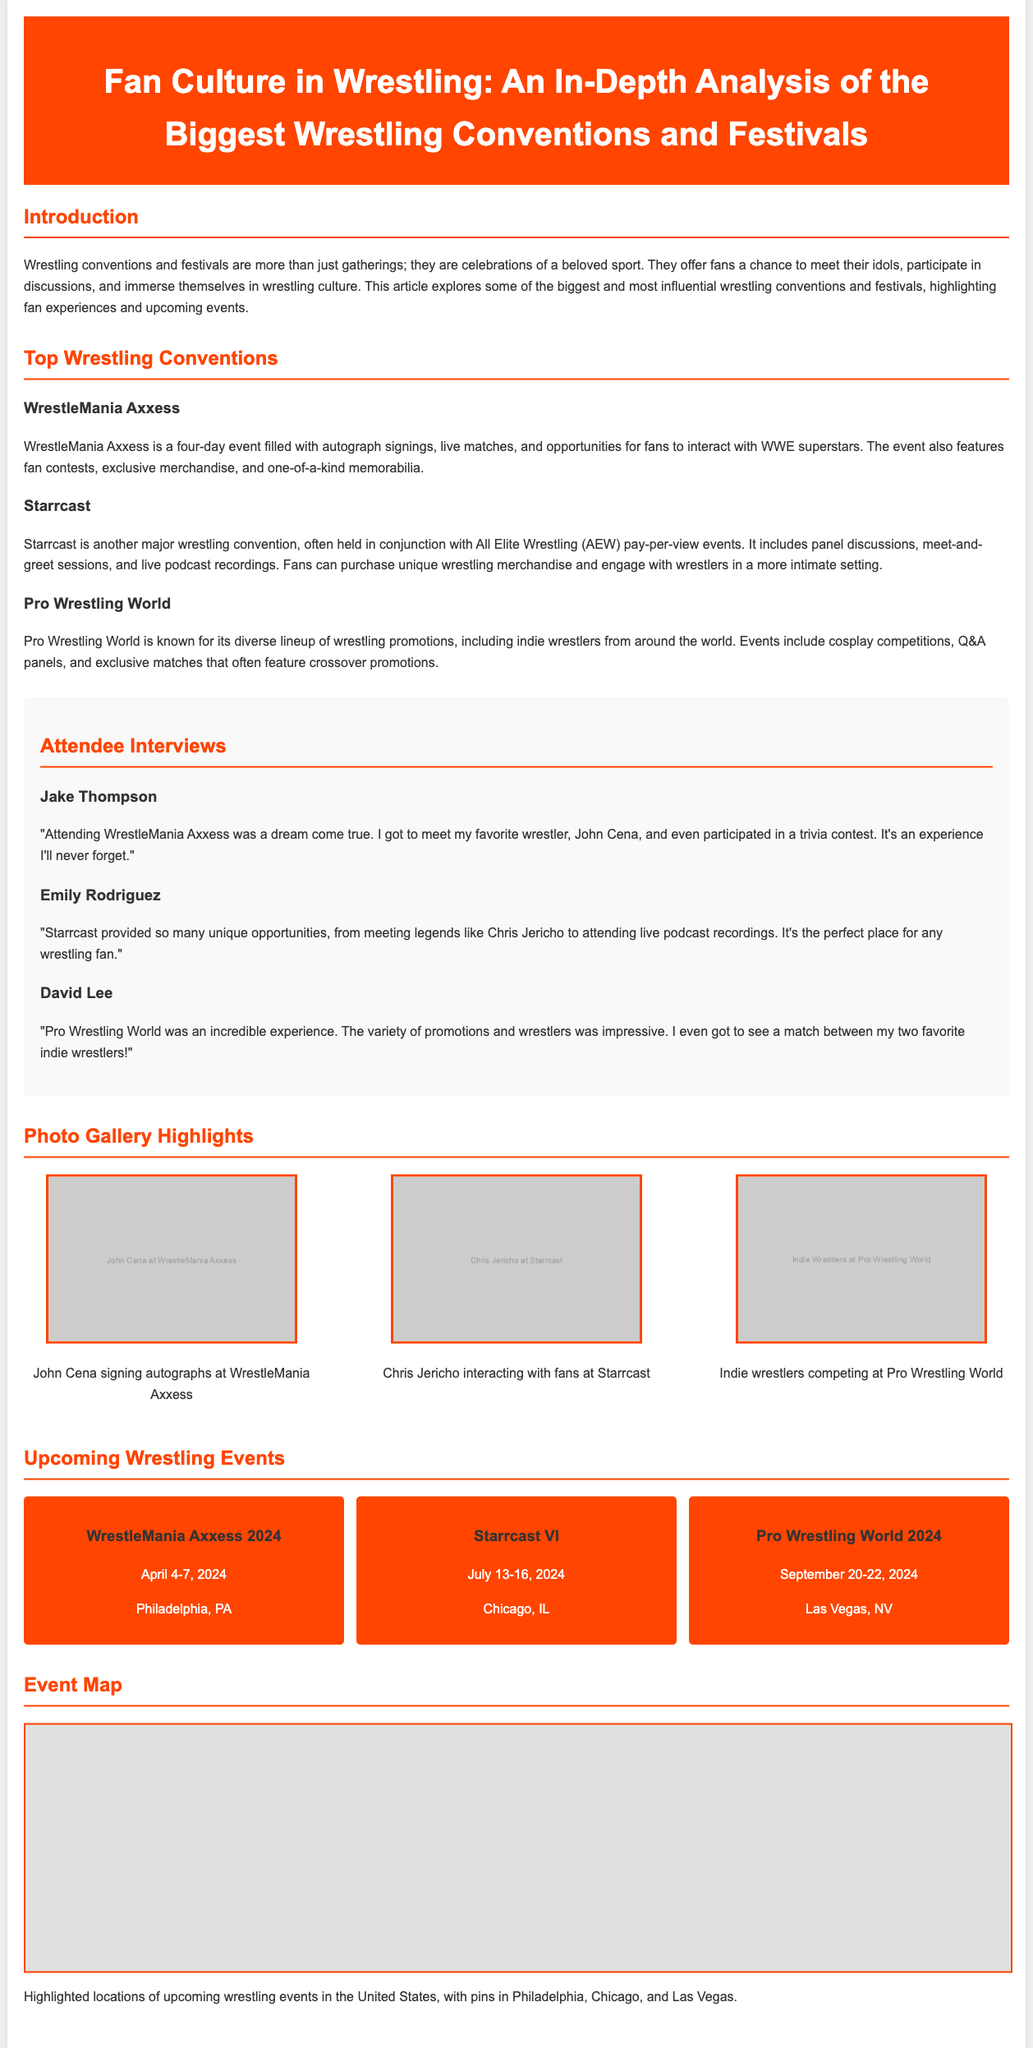what is the title of the document? The title of the document is stated in the header section, which is "Fan Culture in Wrestling: An In-Depth Analysis of the Biggest Wrestling Conventions and Festivals."
Answer: Fan Culture in Wrestling: An In-Depth Analysis of the Biggest Wrestling Conventions and Festivals what date is WrestleMania Axxess 2024 scheduled? The document states that WrestleMania Axxess 2024 is scheduled for April 4-7, 2024.
Answer: April 4-7, 2024 who is quoted saying they met John Cena? The interview section quotes Jake Thompson as saying he met John Cena.
Answer: Jake Thompson how many wrestling conventions are highlighted in the document? The document lists three wrestling conventions: WrestleMania Axxess, Starrcast, and Pro Wrestling World.
Answer: Three where is Pro Wrestling World 2024 taking place? The upcoming event section specifies that Pro Wrestling World 2024 will take place in Las Vegas, NV.
Answer: Las Vegas, NV what type of events does Starrcast include? The document mentions that Starrcast includes panel discussions, meet-and-greet sessions, and live podcast recordings.
Answer: Panel discussions, meet-and-greet sessions, and live podcast recordings how many photos are displayed in the photo gallery? There are three photos displayed in the photo gallery section of the document.
Answer: Three what is emphasized in the event map section? The document states that the event map highlights locations of upcoming wrestling events in the United States.
Answer: Locations of upcoming wrestling events in the United States 